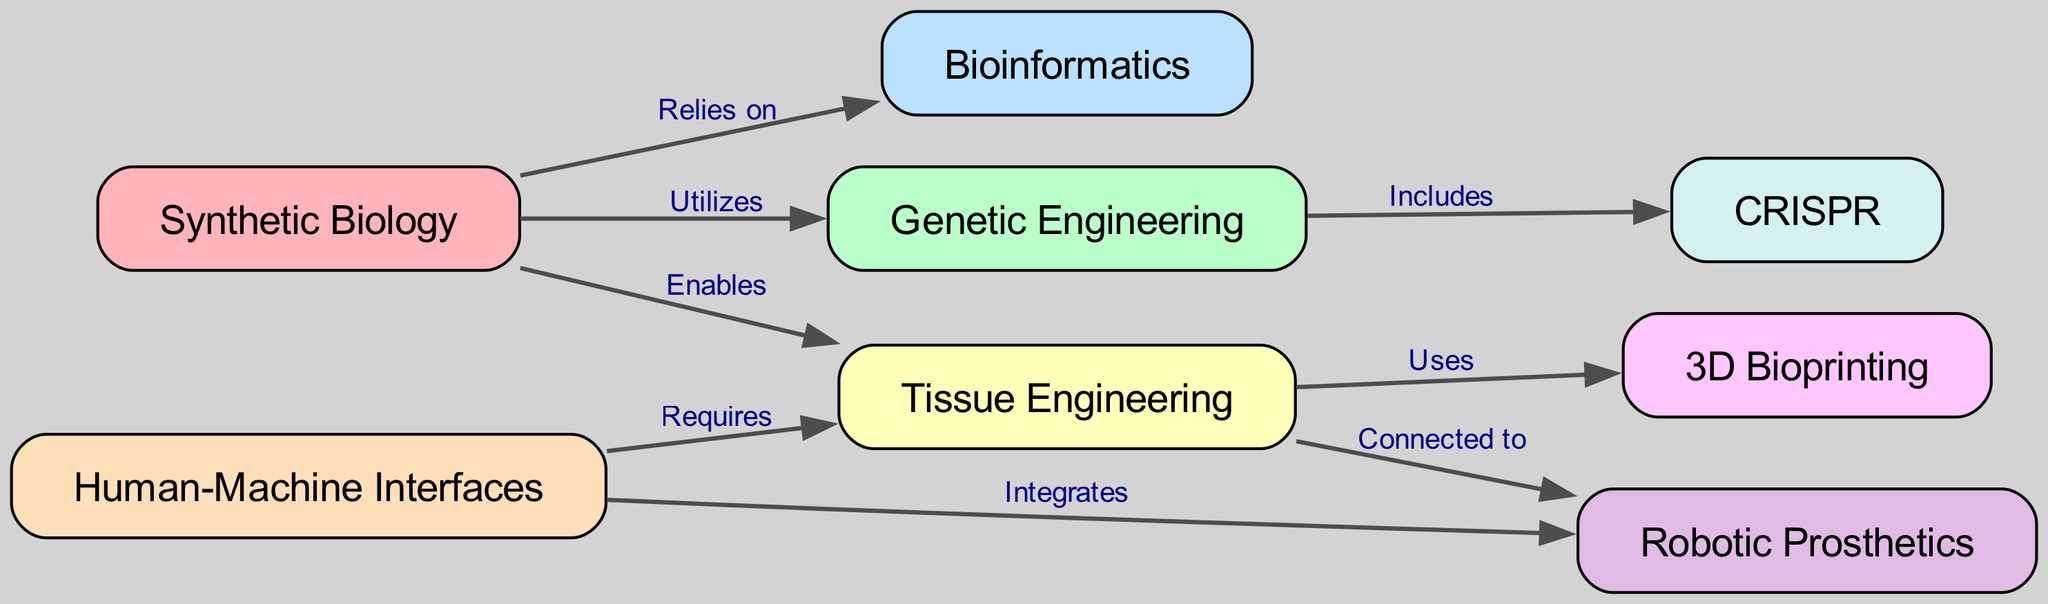What is the main subject of the diagram? The title of the diagram indicates that the focus is on "Synthetic Biology," which is represented by the first node in the diagram.
Answer: Synthetic Biology How many nodes are there in total? By counting each entry under the "nodes" section of the data, there are a total of 8 nodes listed in the diagram.
Answer: 8 What relationship connects Genetic Engineering and CRISPR? The edge connecting Genetic Engineering (node 2) to CRISPR (node 7) is labeled "Includes," indicating that CRISPR is a part of the broader field of Genetic Engineering.
Answer: Includes Which node connects to both Tissue Engineering and Robotic Prosthetics? The edge originating from Tissue Engineering (node 4) leads to Robotic Prosthetics (node 6), showing the connection between these two fields in the diagram.
Answer: Tissue Engineering What field relies on Bioinformatics? The edge from Synthetic Biology (node 1) to Bioinformatics (node 3) is marked with "Relies on," indicating that Synthetic Biology depends on Bioinformatics for its functions.
Answer: Synthetic Biology What process uses 3D Bioprinting? Tissue Engineering (node 4) is connected to 3D Bioprinting (node 8) with the edge labeled "Uses," demonstrating that Tissue Engineering employs 3D Bioprinting as part of its methodology.
Answer: Tissue Engineering What does the Human-Machine Interfaces node require? The edge connecting Human-Machine Interfaces (node 5) to Tissue Engineering (node 4) is labeled "Requires," indicating that Human-Machine Interfaces depend on Tissue Engineering.
Answer: Tissue Engineering What is the relationship between Human-Machine Interfaces and Robotic Prosthetics? The edge from Human-Machine Interfaces (node 5) to Robotic Prosthetics (node 6) is labeled "Integrates," thereby showing that these two areas combine their technologies and concepts.
Answer: Integrates 